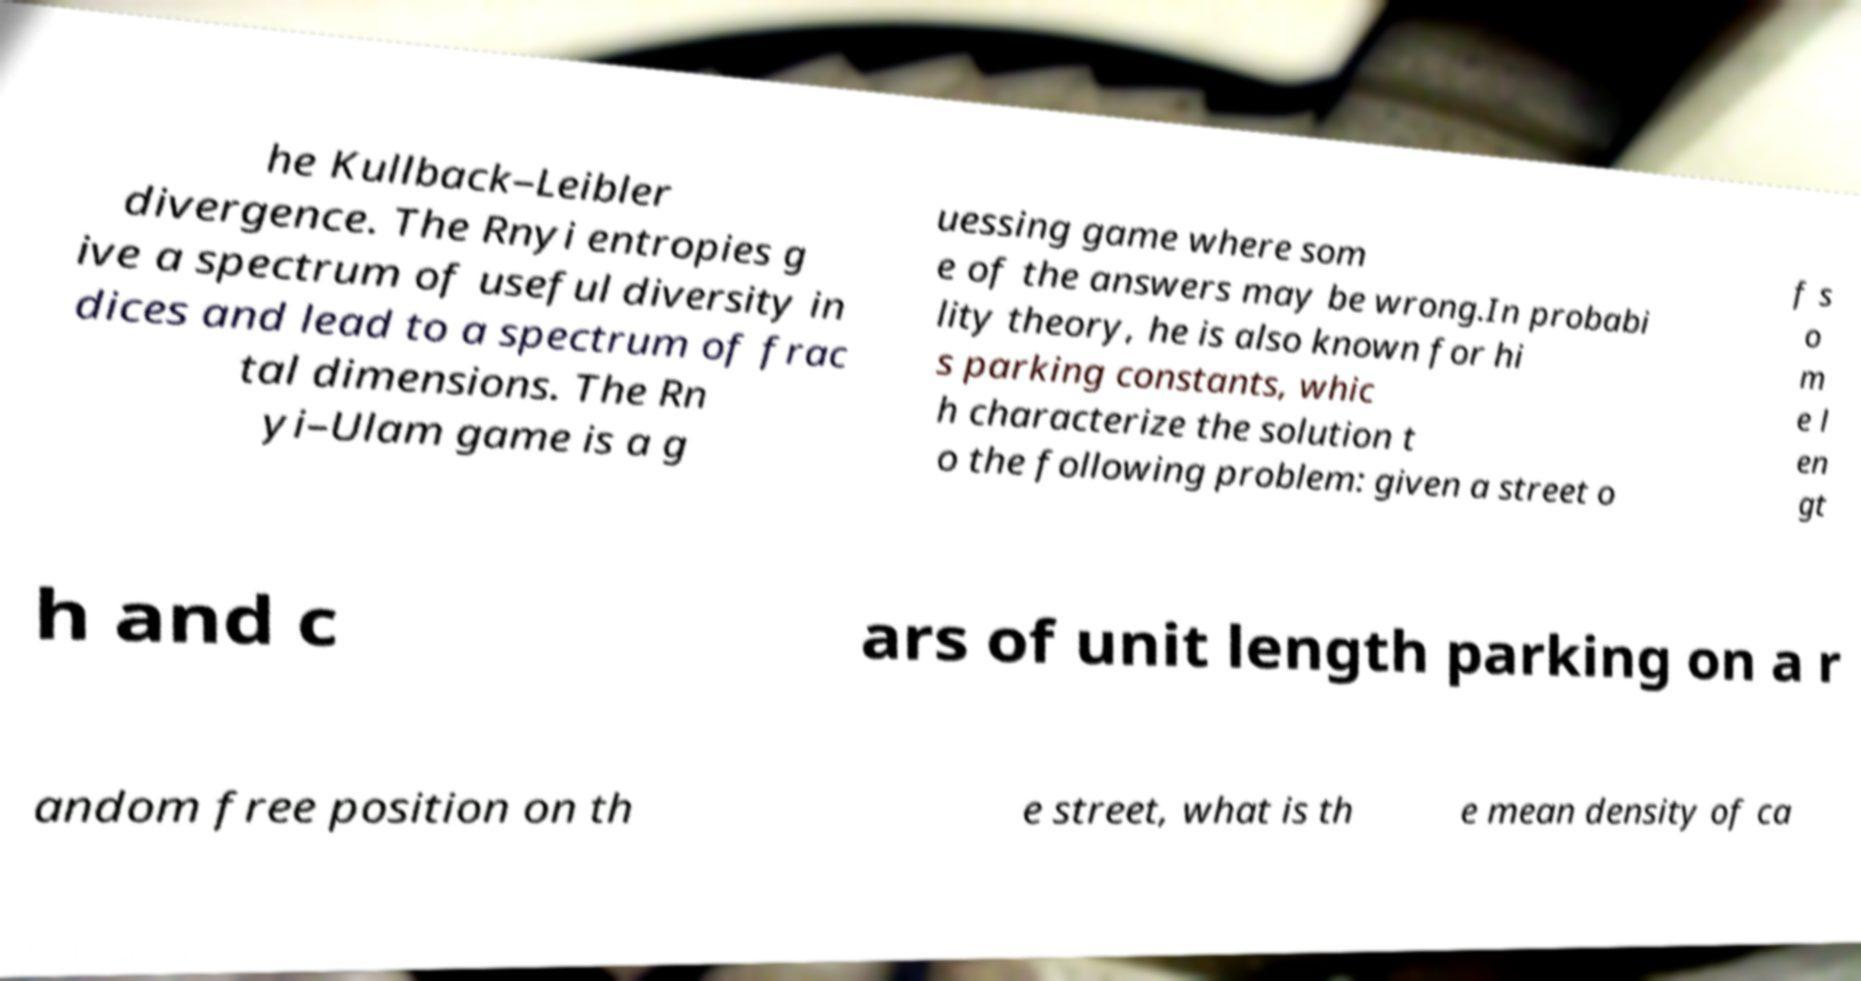Please identify and transcribe the text found in this image. he Kullback–Leibler divergence. The Rnyi entropies g ive a spectrum of useful diversity in dices and lead to a spectrum of frac tal dimensions. The Rn yi–Ulam game is a g uessing game where som e of the answers may be wrong.In probabi lity theory, he is also known for hi s parking constants, whic h characterize the solution t o the following problem: given a street o f s o m e l en gt h and c ars of unit length parking on a r andom free position on th e street, what is th e mean density of ca 